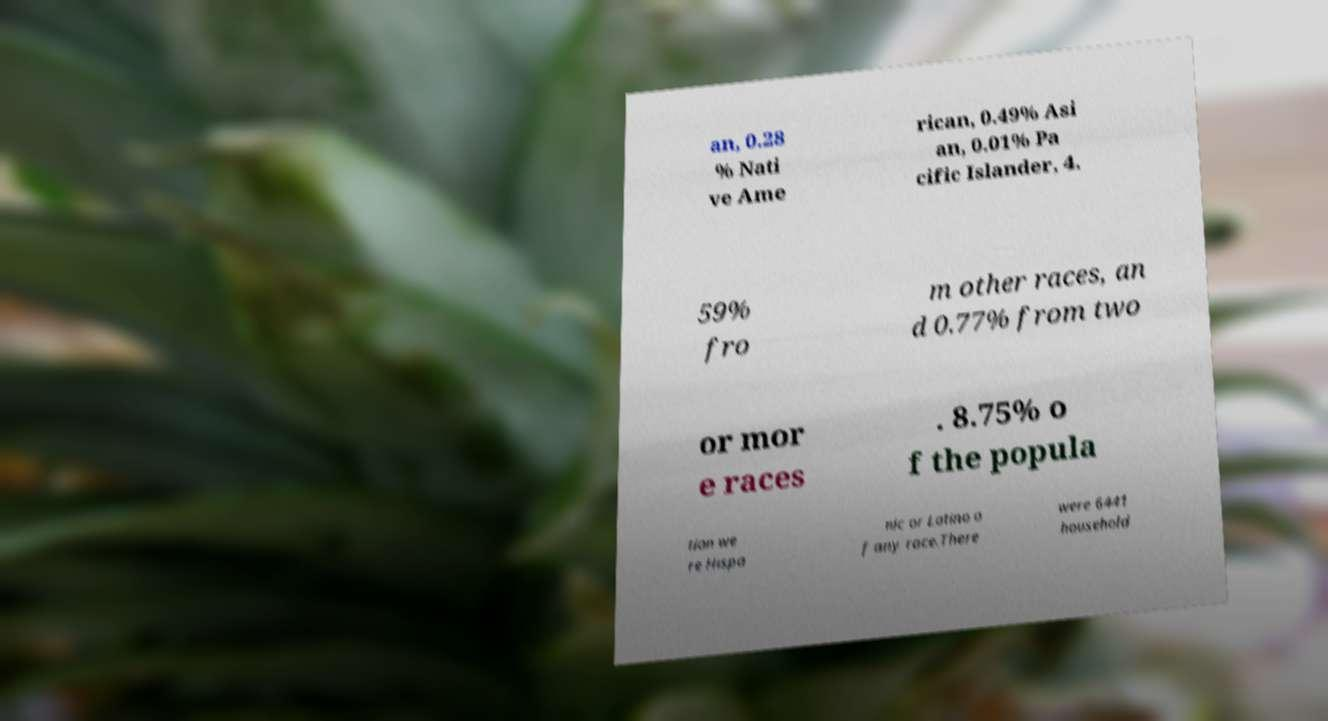For documentation purposes, I need the text within this image transcribed. Could you provide that? an, 0.28 % Nati ve Ame rican, 0.49% Asi an, 0.01% Pa cific Islander, 4. 59% fro m other races, an d 0.77% from two or mor e races . 8.75% o f the popula tion we re Hispa nic or Latino o f any race.There were 6441 household 